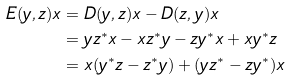Convert formula to latex. <formula><loc_0><loc_0><loc_500><loc_500>E ( y , z ) x & = D ( y , z ) x - D ( z , y ) x \\ & = y z ^ { * } x - x z ^ { * } y - z y ^ { * } x + x y ^ { * } z \\ & = x ( y ^ { * } z - z ^ { * } y ) + ( y z ^ { * } - z y ^ { * } ) x</formula> 